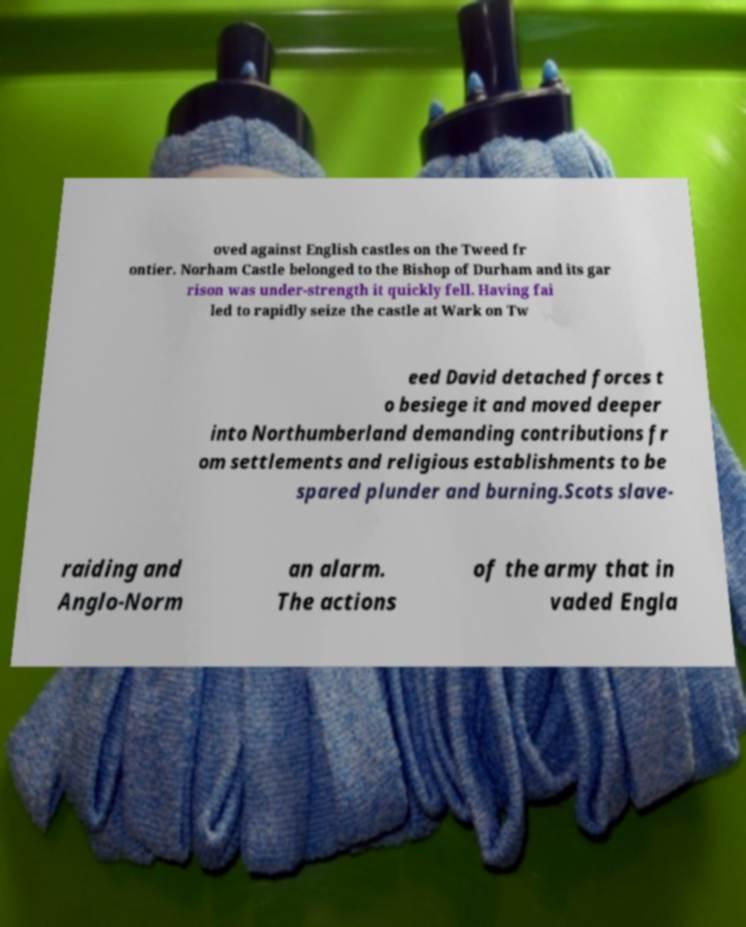What messages or text are displayed in this image? I need them in a readable, typed format. oved against English castles on the Tweed fr ontier. Norham Castle belonged to the Bishop of Durham and its gar rison was under-strength it quickly fell. Having fai led to rapidly seize the castle at Wark on Tw eed David detached forces t o besiege it and moved deeper into Northumberland demanding contributions fr om settlements and religious establishments to be spared plunder and burning.Scots slave- raiding and Anglo-Norm an alarm. The actions of the army that in vaded Engla 